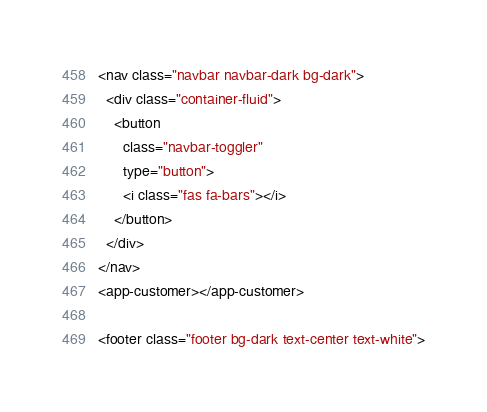Convert code to text. <code><loc_0><loc_0><loc_500><loc_500><_HTML_><nav class="navbar navbar-dark bg-dark">
  <div class="container-fluid">
    <button
      class="navbar-toggler"
      type="button">
      <i class="fas fa-bars"></i>
    </button>
  </div>
</nav>
<app-customer></app-customer>

<footer class="footer bg-dark text-center text-white"></code> 